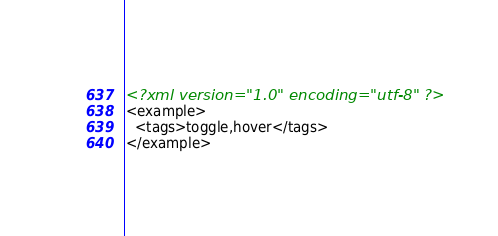Convert code to text. <code><loc_0><loc_0><loc_500><loc_500><_XML_><?xml version="1.0" encoding="utf-8" ?>
<example>
  <tags>toggle,hover</tags>
</example></code> 